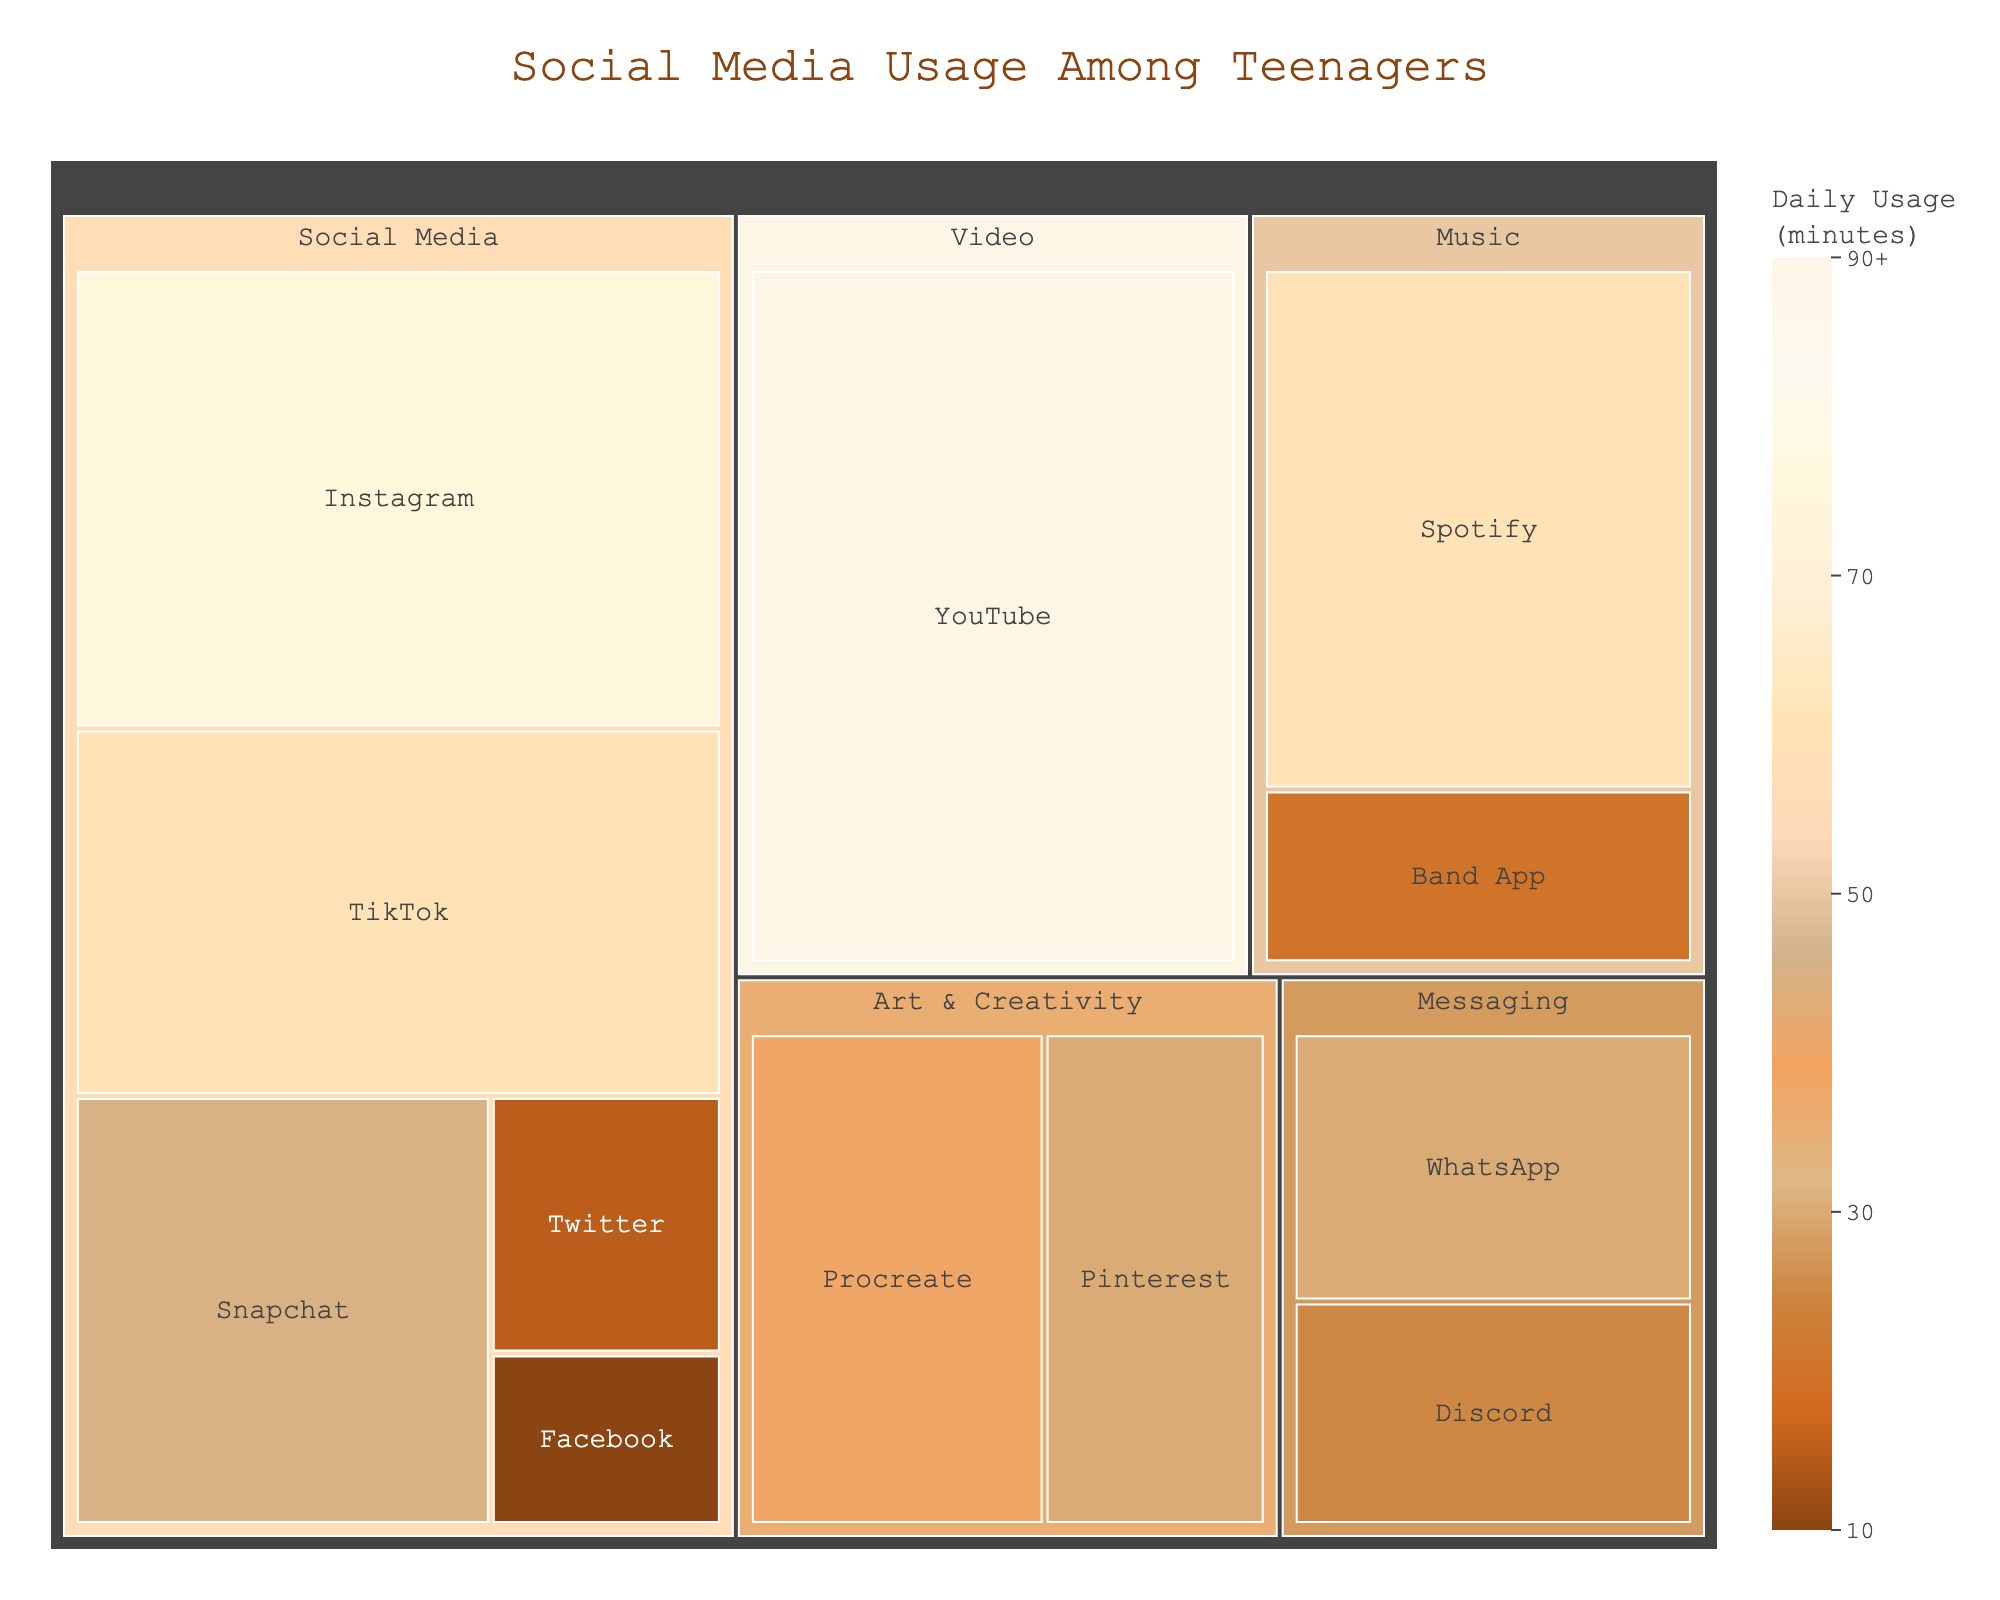what is the title of the figure? The title is located at the top of the treemap. It provides an overview of what the figure is about.
Answer: Social Media Usage Among Teenagers How much time do teenagers spend on 'Instagram' daily according to the figure? Find the 'Instagram' tile within the treemap. Check the associated daily usage value next to it.
Answer: 75 minutes Which category has the highest average daily time spent on apps? To determine this, look at the total sizes of the categories. The Video category visually appears to have the largest area. Most tiles within the Video category have high individual usage times, specifically YouTube at 90 minutes.
Answer: Video What is the total daily usage for apps categorized under 'Art & Creativity'? For this, sum the daily usage of apps under 'Art & Creativity' (Pinterest: 30 minutes + Procreate: 40 minutes).
Answer: 70 minutes Compare daily usage: Is 'YouTube' usage greater than the combined usage of 'Instagram' and 'Snapchat'? First, sum the usage of 'Instagram' and 'Snapchat' (75 + 45 = 120 minutes). Then, compare this sum to the usage of 'YouTube' (90 minutes vs. 120 minutes).
Answer: No Between 'Facebook' and 'Twitter', which app has a higher daily usage? Locate the tiles for 'Facebook' and 'Twitter'. Compare the daily usage values next to each tile.
Answer: Twitter How many minutes do teenagers spend on 'Messaging' apps daily? Sum the daily usage values of apps categorized under 'Messaging' (WhatsApp: 30 minutes + Discord: 25 minutes).
Answer: 55 minutes What's the difference in daily usage time between 'Spotify' and 'Band App'? Subtract the daily usage of 'Band App' from 'Spotify' (60 - 20 minutes).
Answer: 40 minutes How is the 'Social Media' category visualized in terms of app usage? Review the 'Social Media' tiles. Notice the variations in area sizes and the range of colors in these tiles, indicating differing usage times.
Answer: Varies from large (e.g., Instagram: 75 minutes) to small (e.g., Facebook: 10 minutes) Which app in the 'Music' category has higher daily usage, 'Spotify' or 'Band App'? Locate both apps within the 'Music' category. Compare their daily usage values.
Answer: Spotify 